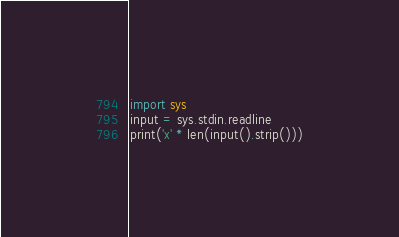<code> <loc_0><loc_0><loc_500><loc_500><_Python_>import sys
input = sys.stdin.readline
print('x' * len(input().strip()))
</code> 